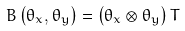<formula> <loc_0><loc_0><loc_500><loc_500>B \left ( \theta _ { x } , \theta _ { y } \right ) = \left ( \theta _ { x } \otimes \theta _ { y } \right ) T</formula> 